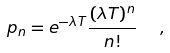<formula> <loc_0><loc_0><loc_500><loc_500>p _ { n } = e ^ { - \lambda T } \frac { ( \lambda T ) ^ { n } } { n ! } \ \ ,</formula> 